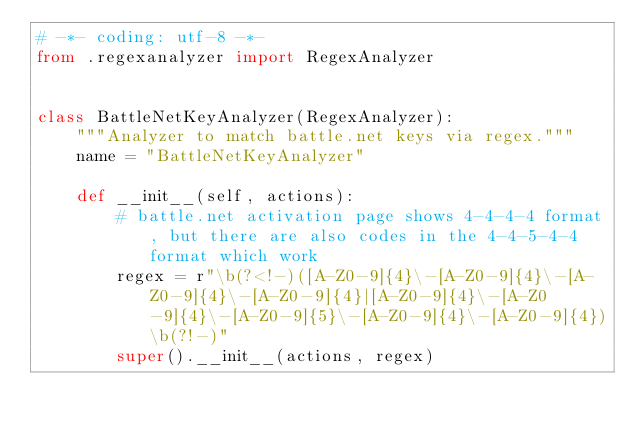Convert code to text. <code><loc_0><loc_0><loc_500><loc_500><_Python_># -*- coding: utf-8 -*-
from .regexanalyzer import RegexAnalyzer


class BattleNetKeyAnalyzer(RegexAnalyzer):
    """Analyzer to match battle.net keys via regex."""
    name = "BattleNetKeyAnalyzer"

    def __init__(self, actions):
        # battle.net activation page shows 4-4-4-4 format, but there are also codes in the 4-4-5-4-4 format which work
        regex = r"\b(?<!-)([A-Z0-9]{4}\-[A-Z0-9]{4}\-[A-Z0-9]{4}\-[A-Z0-9]{4}|[A-Z0-9]{4}\-[A-Z0-9]{4}\-[A-Z0-9]{5}\-[A-Z0-9]{4}\-[A-Z0-9]{4})\b(?!-)"
        super().__init__(actions, regex)
</code> 